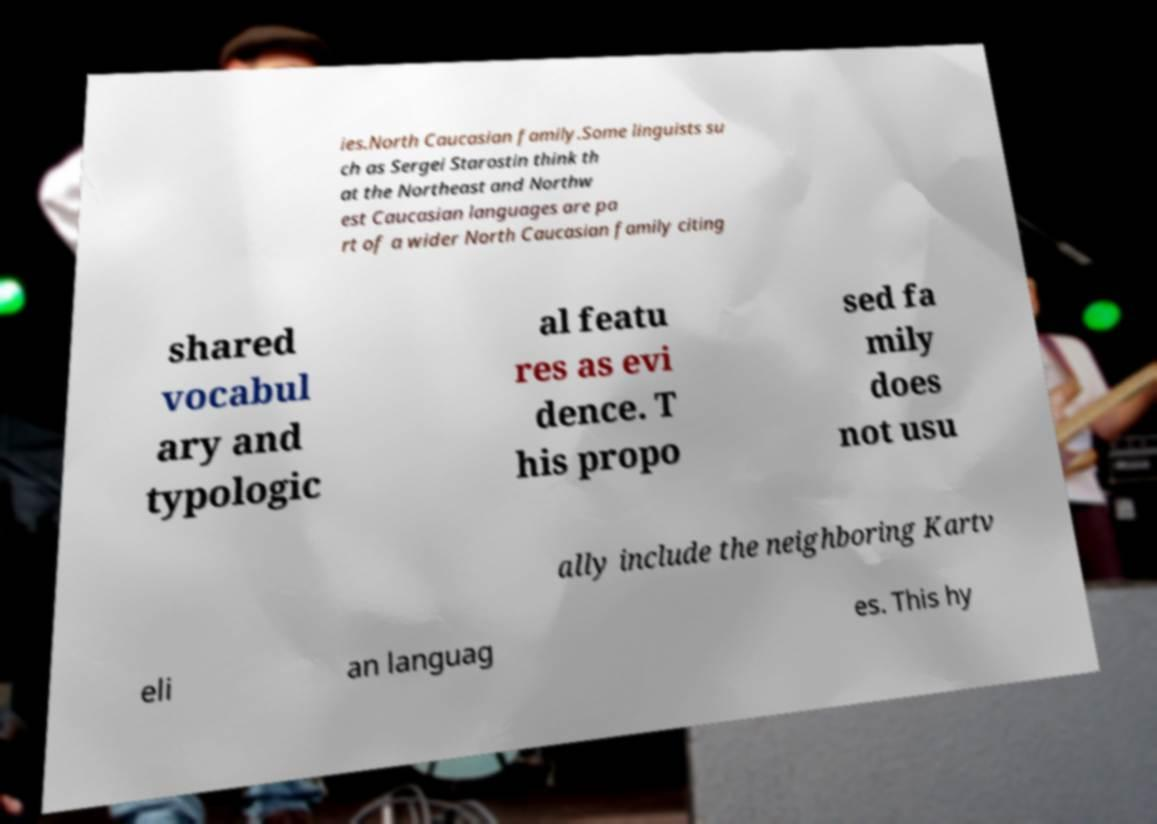There's text embedded in this image that I need extracted. Can you transcribe it verbatim? ies.North Caucasian family.Some linguists su ch as Sergei Starostin think th at the Northeast and Northw est Caucasian languages are pa rt of a wider North Caucasian family citing shared vocabul ary and typologic al featu res as evi dence. T his propo sed fa mily does not usu ally include the neighboring Kartv eli an languag es. This hy 